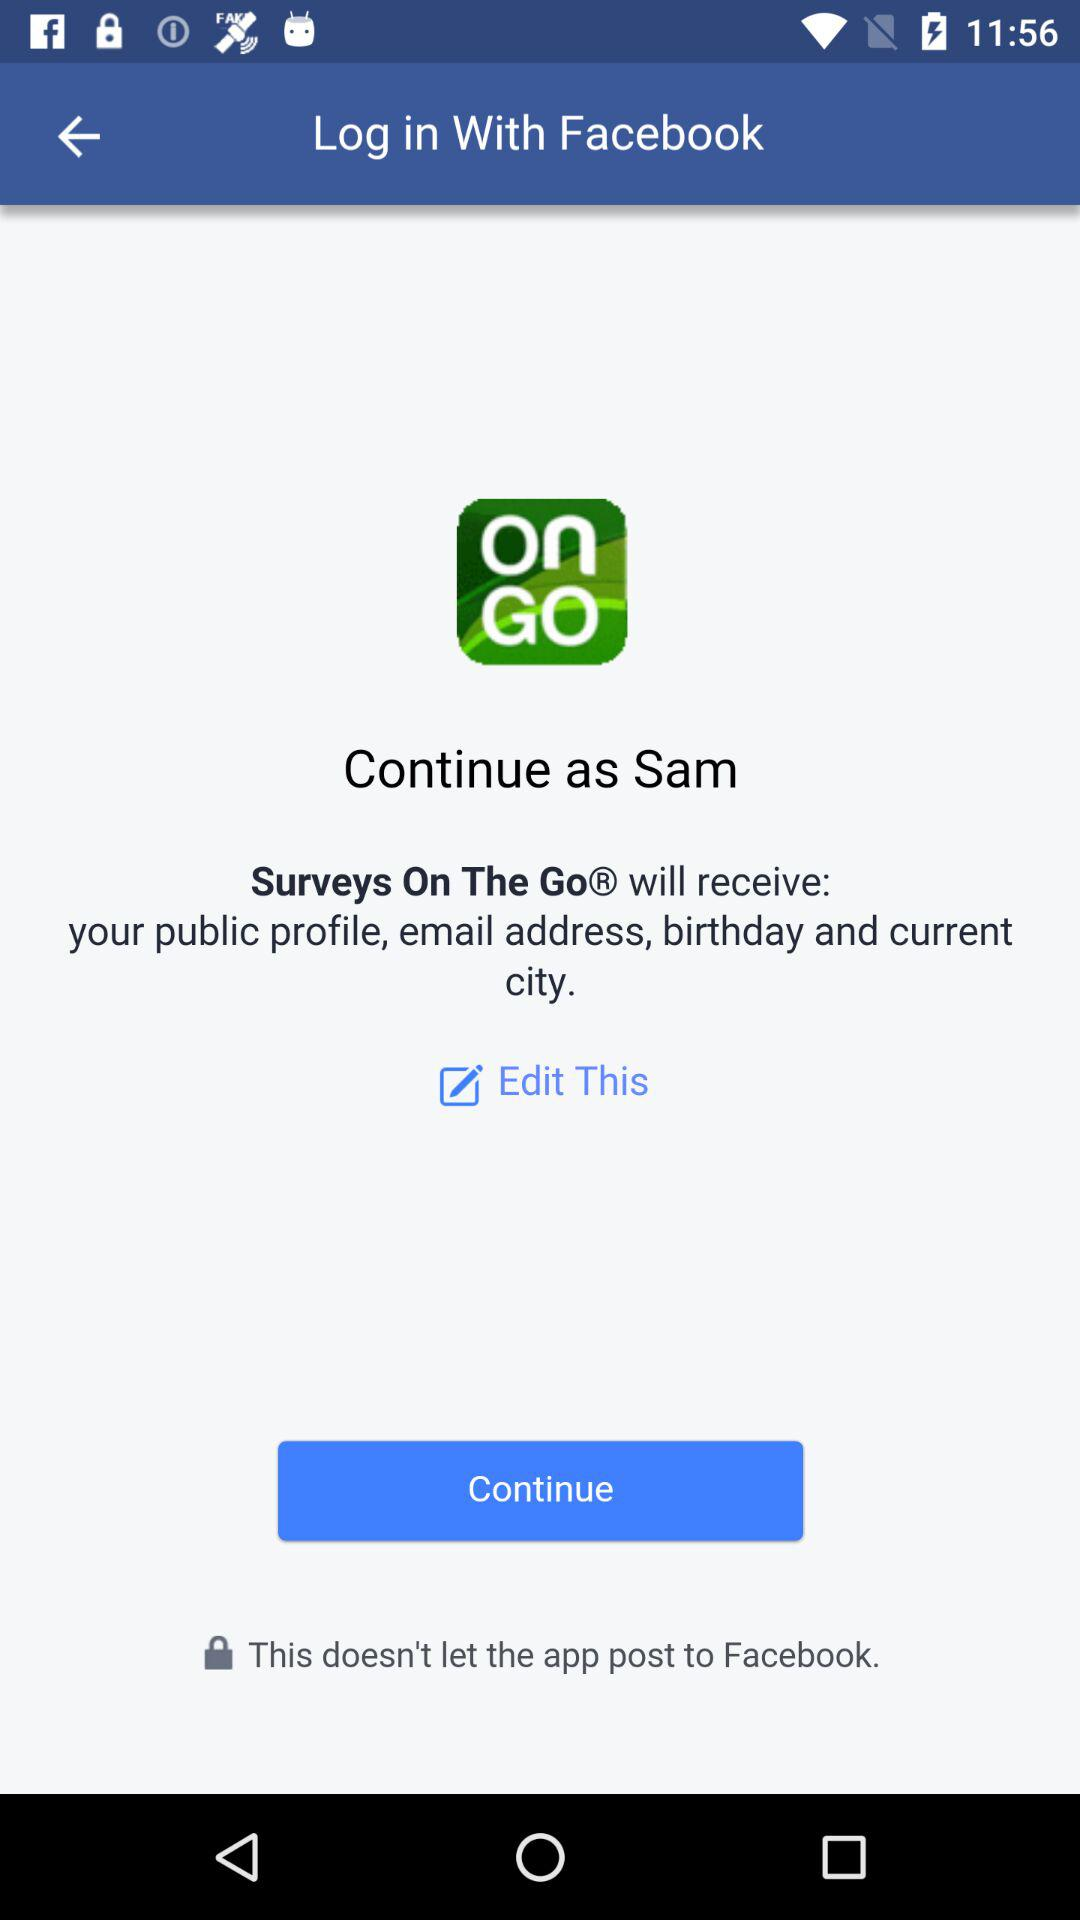Which application is in use? The application that is in use is "Surveys On The Go". 